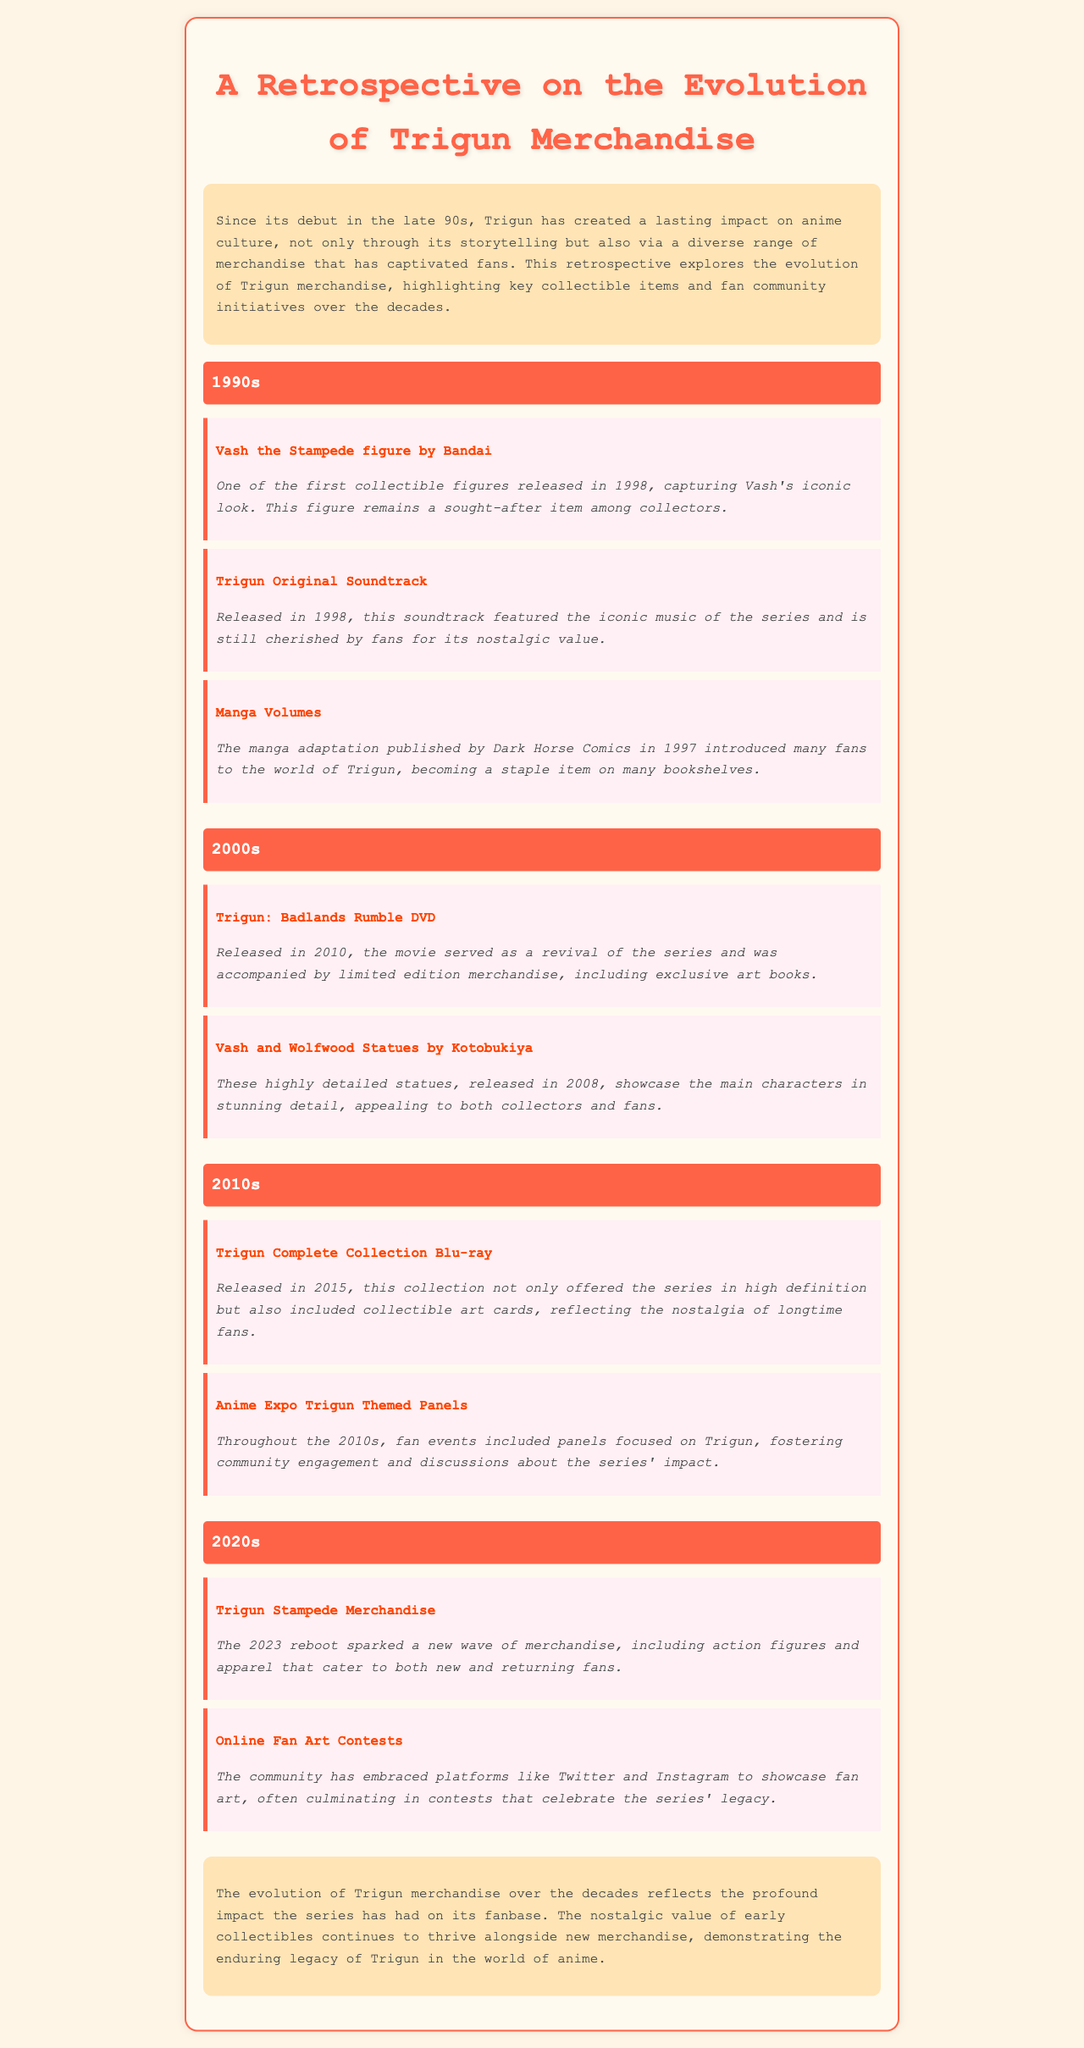what year was the Vash the Stampede figure released? The document states that the Vash the Stampede figure by Bandai was released in 1998.
Answer: 1998 what is a collectible item from the 2000s? The document lists the Trigun: Badlands Rumble DVD as a collectible item released in the 2000s.
Answer: Trigun: Badlands Rumble DVD which company produced the Vash and Wolfwood statues? The document mentions that these statues were produced by Kotobukiya.
Answer: Kotobukiya how many decades are discussed in the document? The document discusses merchandise evolution over four decades: 1990s, 2000s, 2010s, and 2020s.
Answer: Four what type of event fostered community engagement in the 2010s? The document notes that Anime Expo Trigun themed panels fostered community engagement.
Answer: Anime Expo Trigun Themed Panels what merchandise was released with the 2023 reboot? The document states that the Trigun Stampede Merchandise was released alongside the reboot.
Answer: Trigun Stampede Merchandise what year was the Trigun Complete Collection Blu-ray released? According to the document, it was released in 2015.
Answer: 2015 what type of fan community initiative is mentioned for the 2020s? The document mentions online fan art contests as an initiative for the community.
Answer: Online Fan Art Contests 